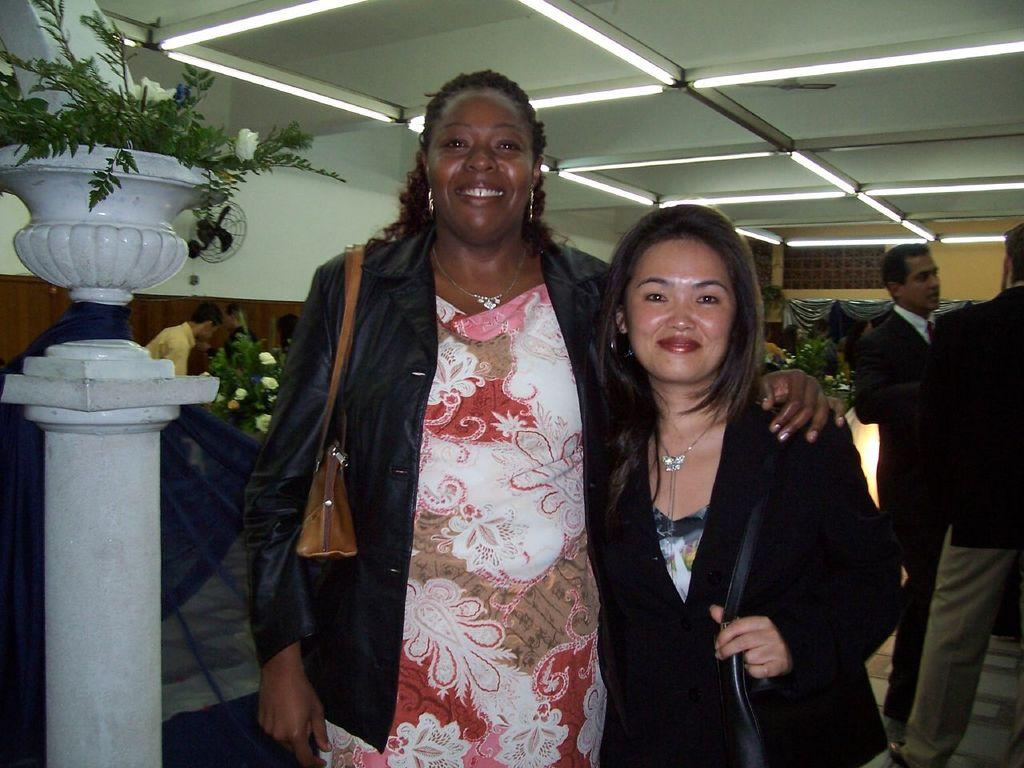What can be seen in the image involving human presence? There are people standing in the image. What type of vegetation is present in the image? There is a plant in the image. What architectural feature is visible on the roof in the image? There are lights on the roof in the image. What word is the parent teaching the child in the image? There is no child or parent present in the image, and therefore no such interaction can be observed. What is the mindset of the plant in the image? Plants do not have minds or mindsets, so this question cannot be answered. 